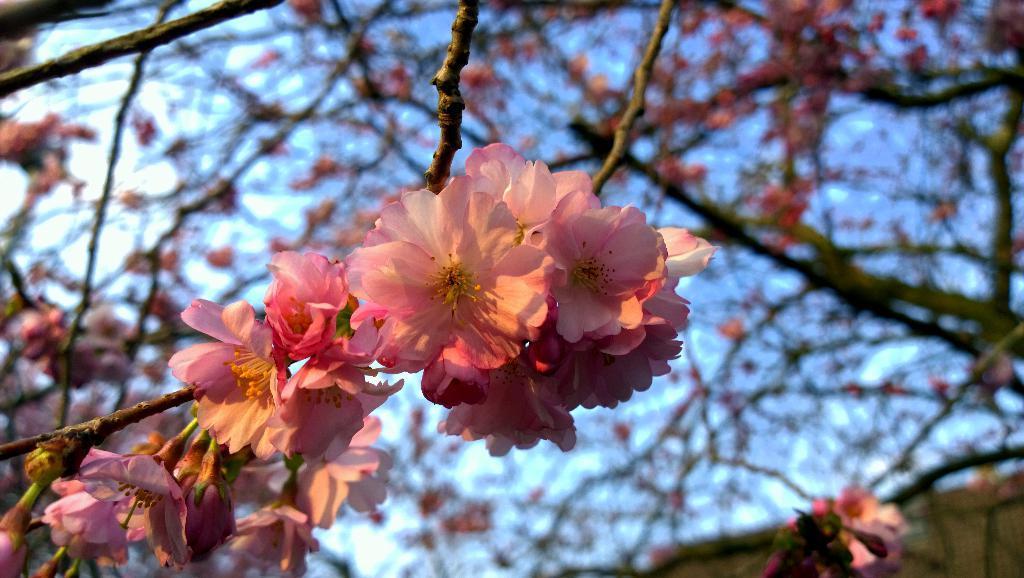Please provide a concise description of this image. In this image we can see some flowers and stems. In the background of the image there is a blur background. 